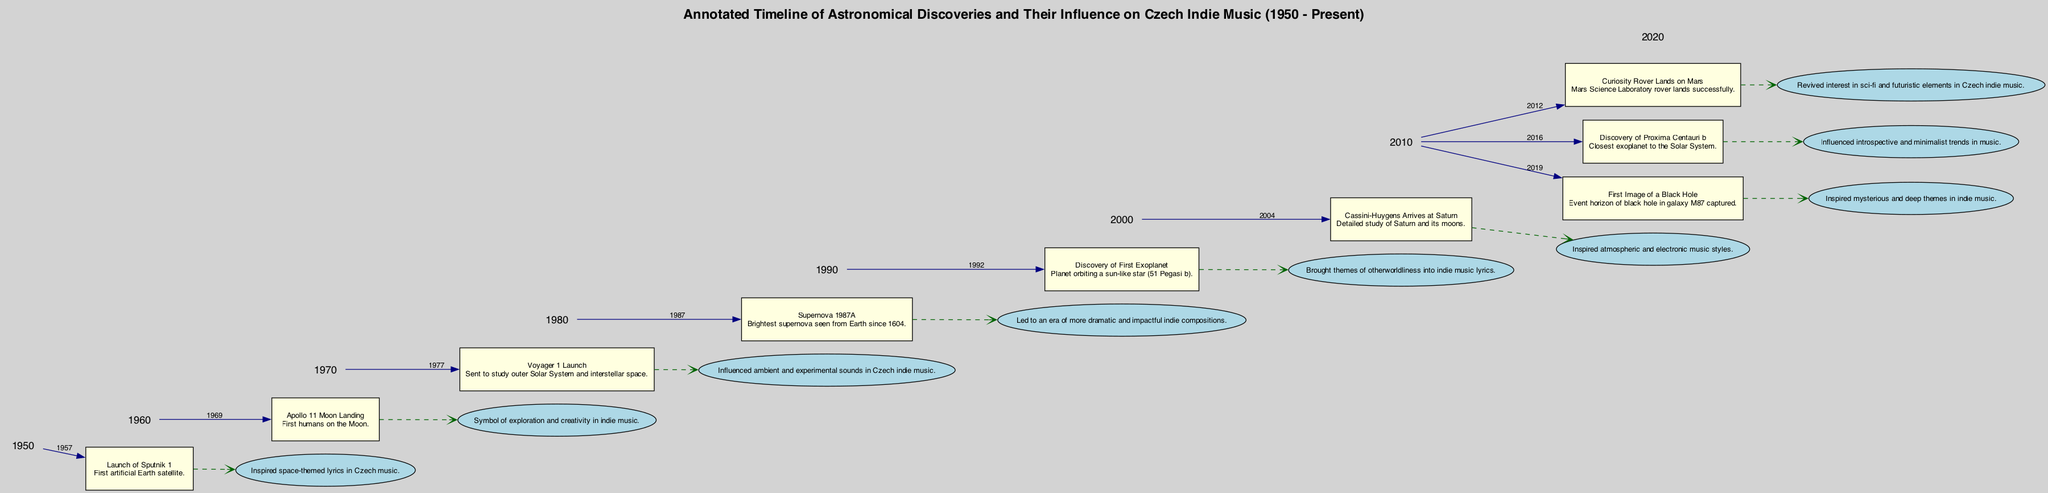What event took place in 1969? The diagram indicates that the event in 1969 is the Apollo 11 Moon Landing. This can be found directly in the timeline where the event nodes are connected with the year labels.
Answer: Apollo 11 Moon Landing Which event is connected to the concept of "otherworldliness"? By examining the influence node connected to the event of discovering the first exoplanet in 1992, it states that this discovery brought themes of otherworldliness into indie music lyrics. This requires correlating the event with its described influence in the timeline.
Answer: Discovery of First Exoplanet How many events occurred before 1987? Counting the event nodes prior to 1987 in the timeline, we see there are three notable events: the launch of Sputnik 1 in 1957, the Apollo 11 Moon Landing in 1969, and the launch of Voyager 1 in 1977. This involves a straightforward count of the nodes associated with years before 1987.
Answer: 3 What did the 2012 Curiosity Rover landing inspire in Czech indie music? The diagram specifies that the landing of the Curiosity Rover on Mars in 2012 revived interest in sci-fi and futuristic elements in Czech indie music. This can be determined by looking at the influence connected to that particular event node.
Answer: Sci-fi and futuristic elements Which event is noted for influencing ambient sounds in Czech indie music? The event that is associated with influencing ambient and experimental sounds in Czech indie music is the launch of Voyager 1 in 1977. The influence node connected to this event specifies this clearly, linking both the description and influence.
Answer: Voyager 1 Launch What year marked the first image of a black hole? According to the diagram, the first image of a black hole was taken in 2019. This can be directly identified from the event node for that year in the timeline.
Answer: 2019 Which astronomical event led to a shift towards more dramatic indie compositions? The event of Supernova 1987A in 1987 is identified in the diagram as having led to an era of more dramatic and impactful indie compositions. This requires extracting the information about the influence from the Supernova's event node.
Answer: Supernova 1987A How does the discovery in 2016 relate to the music trends? The discovery of Proxima Centauri b in 2016 is shown to have influenced introspective and minimalist trends in music. The relationship is stated in the influence node linked to that particular event, indicating its impact on music style.
Answer: Introspective and minimalist trends 